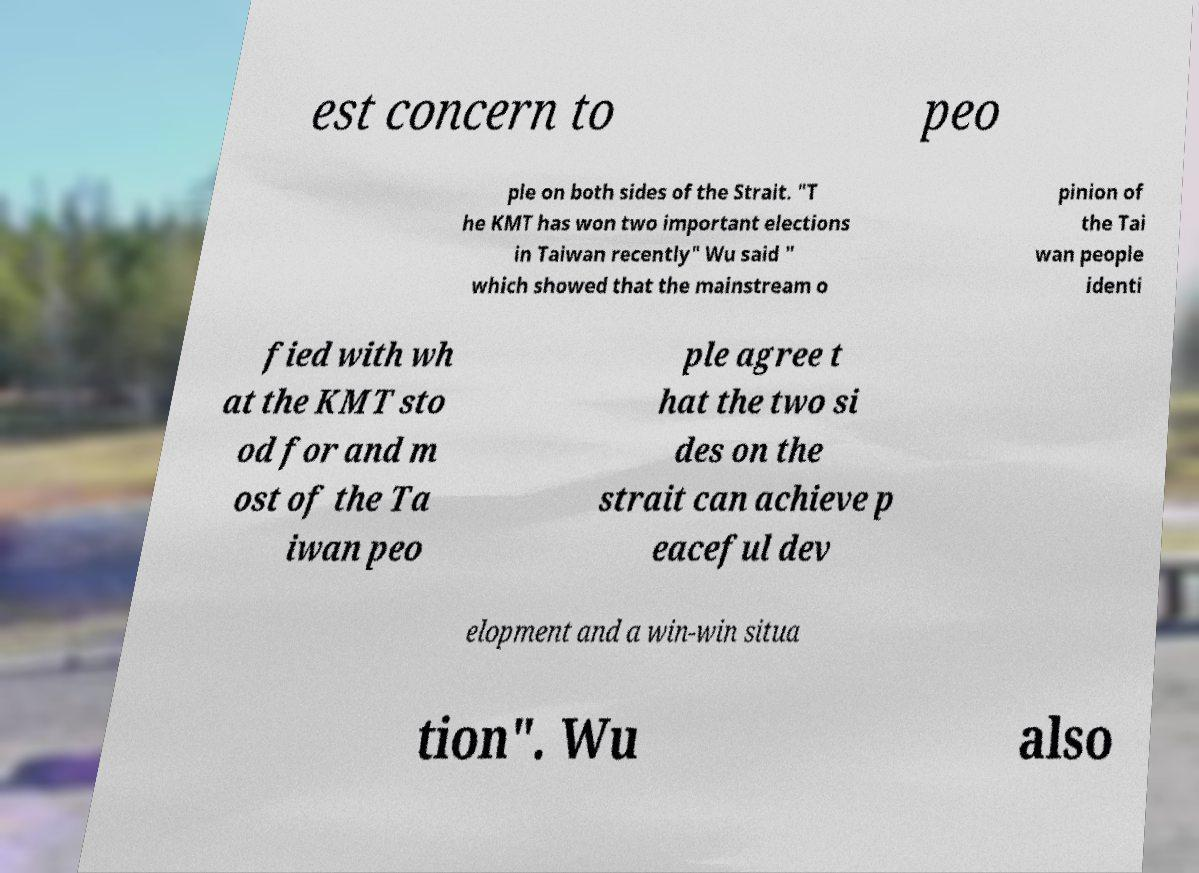I need the written content from this picture converted into text. Can you do that? est concern to peo ple on both sides of the Strait. "T he KMT has won two important elections in Taiwan recently" Wu said " which showed that the mainstream o pinion of the Tai wan people identi fied with wh at the KMT sto od for and m ost of the Ta iwan peo ple agree t hat the two si des on the strait can achieve p eaceful dev elopment and a win-win situa tion". Wu also 